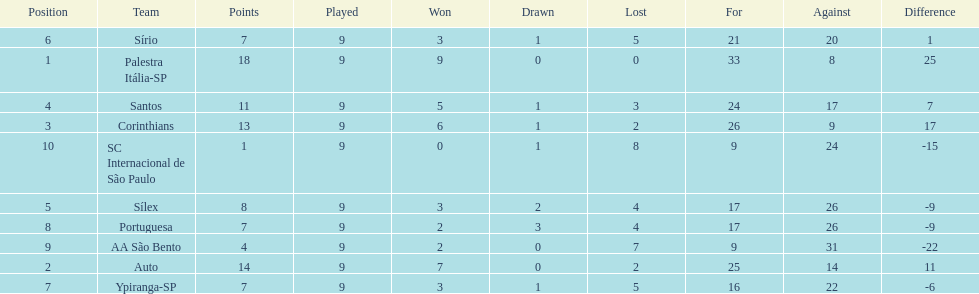How many points did the brazilian football team auto get in 1926? 14. Parse the full table. {'header': ['Position', 'Team', 'Points', 'Played', 'Won', 'Drawn', 'Lost', 'For', 'Against', 'Difference'], 'rows': [['6', 'Sírio', '7', '9', '3', '1', '5', '21', '20', '1'], ['1', 'Palestra Itália-SP', '18', '9', '9', '0', '0', '33', '8', '25'], ['4', 'Santos', '11', '9', '5', '1', '3', '24', '17', '7'], ['3', 'Corinthians', '13', '9', '6', '1', '2', '26', '9', '17'], ['10', 'SC Internacional de São Paulo', '1', '9', '0', '1', '8', '9', '24', '-15'], ['5', 'Sílex', '8', '9', '3', '2', '4', '17', '26', '-9'], ['8', 'Portuguesa', '7', '9', '2', '3', '4', '17', '26', '-9'], ['9', 'AA São Bento', '4', '9', '2', '0', '7', '9', '31', '-22'], ['2', 'Auto', '14', '9', '7', '0', '2', '25', '14', '11'], ['7', 'Ypiranga-SP', '7', '9', '3', '1', '5', '16', '22', '-6']]} 